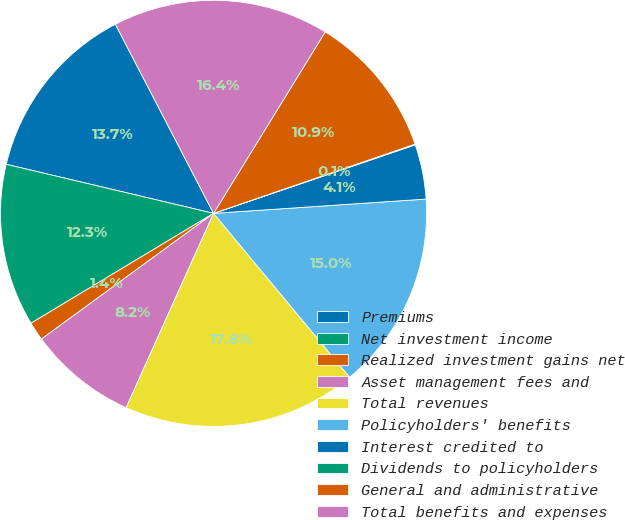Convert chart. <chart><loc_0><loc_0><loc_500><loc_500><pie_chart><fcel>Premiums<fcel>Net investment income<fcel>Realized investment gains net<fcel>Asset management fees and<fcel>Total revenues<fcel>Policyholders' benefits<fcel>Interest credited to<fcel>Dividends to policyholders<fcel>General and administrative<fcel>Total benefits and expenses<nl><fcel>13.68%<fcel>12.32%<fcel>1.42%<fcel>8.23%<fcel>17.76%<fcel>15.04%<fcel>4.14%<fcel>0.06%<fcel>10.95%<fcel>16.4%<nl></chart> 